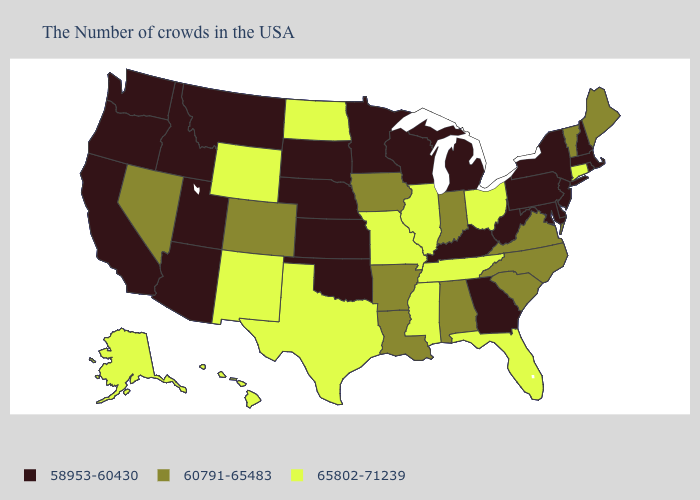Among the states that border Alabama , does Tennessee have the lowest value?
Be succinct. No. Which states hav the highest value in the Northeast?
Answer briefly. Connecticut. Which states hav the highest value in the MidWest?
Concise answer only. Ohio, Illinois, Missouri, North Dakota. Which states have the lowest value in the South?
Keep it brief. Delaware, Maryland, West Virginia, Georgia, Kentucky, Oklahoma. Name the states that have a value in the range 58953-60430?
Write a very short answer. Massachusetts, Rhode Island, New Hampshire, New York, New Jersey, Delaware, Maryland, Pennsylvania, West Virginia, Georgia, Michigan, Kentucky, Wisconsin, Minnesota, Kansas, Nebraska, Oklahoma, South Dakota, Utah, Montana, Arizona, Idaho, California, Washington, Oregon. Name the states that have a value in the range 65802-71239?
Write a very short answer. Connecticut, Ohio, Florida, Tennessee, Illinois, Mississippi, Missouri, Texas, North Dakota, Wyoming, New Mexico, Alaska, Hawaii. Does Maine have the same value as Illinois?
Short answer required. No. How many symbols are there in the legend?
Be succinct. 3. Does Alabama have the lowest value in the South?
Short answer required. No. How many symbols are there in the legend?
Keep it brief. 3. Does the map have missing data?
Quick response, please. No. Among the states that border Idaho , does Nevada have the lowest value?
Concise answer only. No. Does Arkansas have the highest value in the USA?
Keep it brief. No. Which states have the lowest value in the USA?
Quick response, please. Massachusetts, Rhode Island, New Hampshire, New York, New Jersey, Delaware, Maryland, Pennsylvania, West Virginia, Georgia, Michigan, Kentucky, Wisconsin, Minnesota, Kansas, Nebraska, Oklahoma, South Dakota, Utah, Montana, Arizona, Idaho, California, Washington, Oregon. 